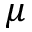Convert formula to latex. <formula><loc_0><loc_0><loc_500><loc_500>\mu</formula> 